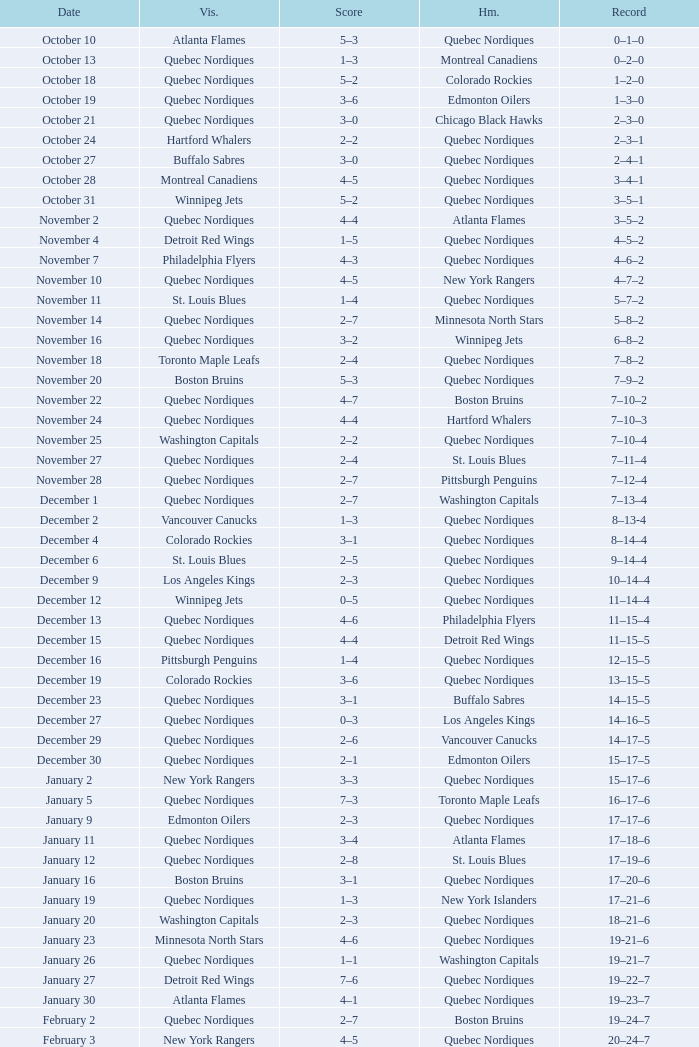Which Home has a Date of april 1? Quebec Nordiques. 